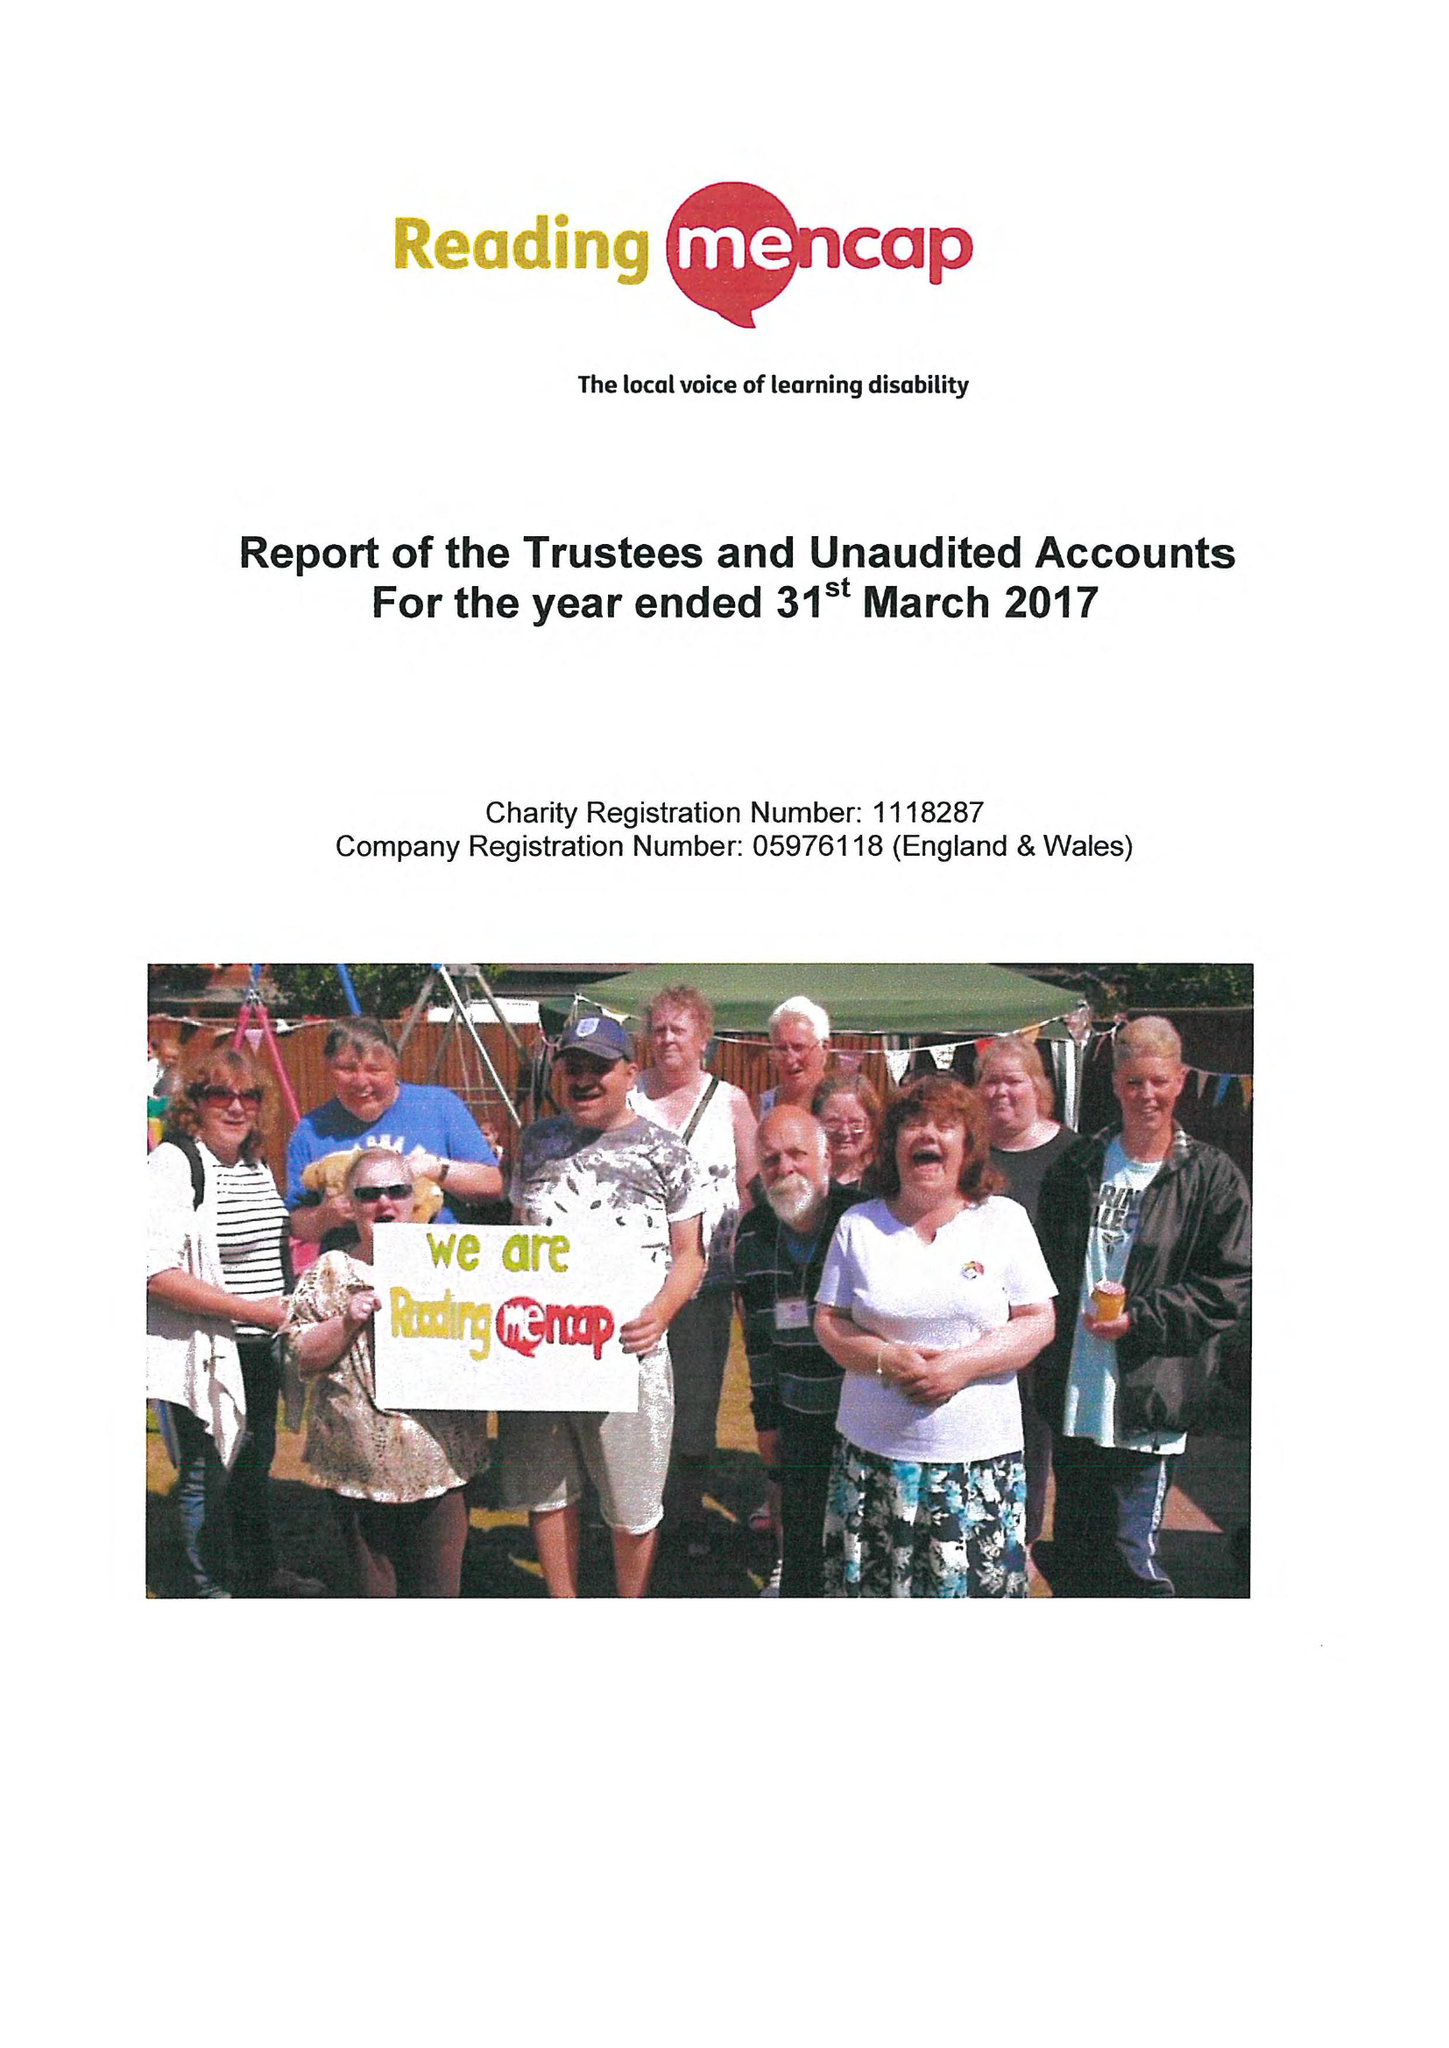What is the value for the charity_name?
Answer the question using a single word or phrase. Reading Mencap 